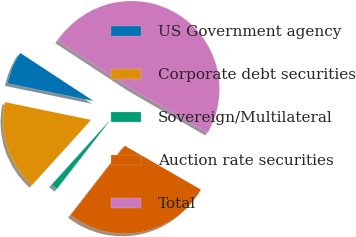<chart> <loc_0><loc_0><loc_500><loc_500><pie_chart><fcel>US Government agency<fcel>Corporate debt securities<fcel>Sovereign/Multilateral<fcel>Auction rate securities<fcel>Total<nl><fcel>6.0%<fcel>16.53%<fcel>1.21%<fcel>27.19%<fcel>49.08%<nl></chart> 